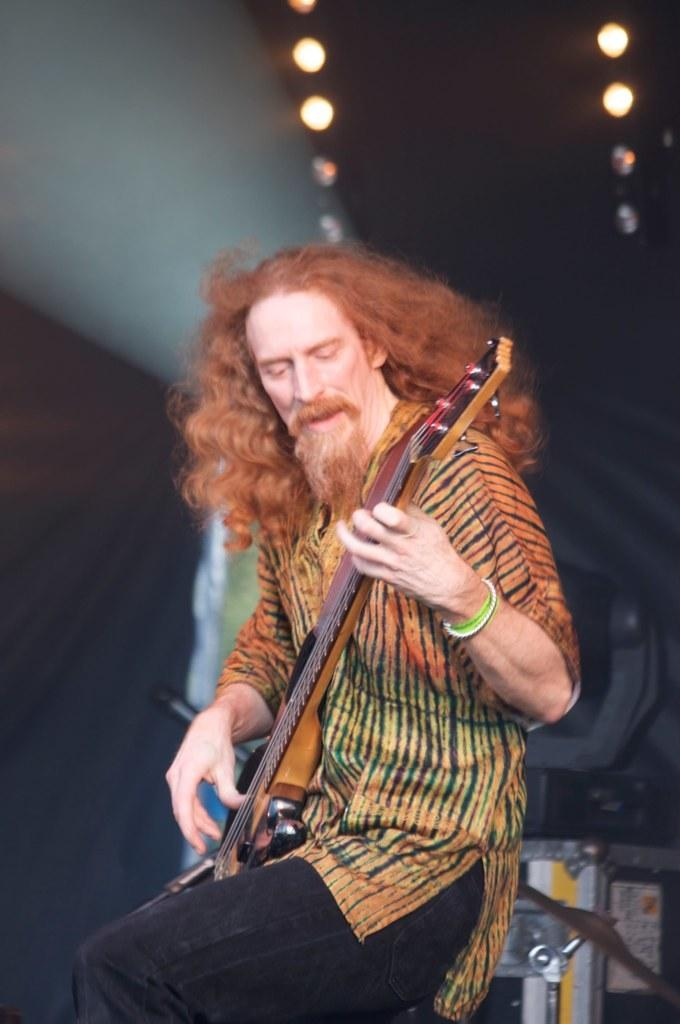What is the man in the image doing? The man is playing a guitar. What is the man sitting on in the image? The man is sitting on a stool. What can be seen in the background of the image? There are lights in the background of the image. What type of stew is being served in the lunchroom in the image? There is no lunchroom or stew present in the image; it features a man playing a guitar while sitting on a stool. What is the man smashing in the image? There is no smashing activity depicted in the image; the man is playing a guitar while sitting on a stool. 